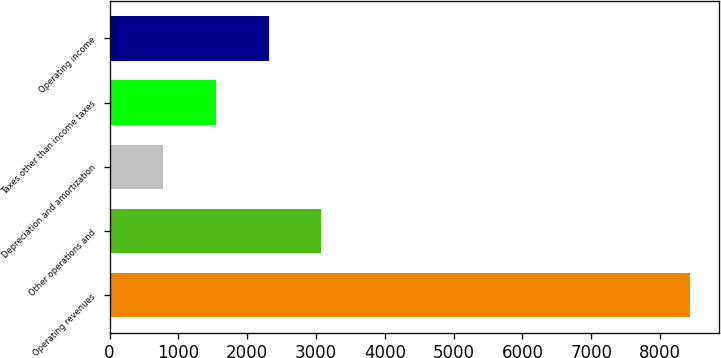Convert chart. <chart><loc_0><loc_0><loc_500><loc_500><bar_chart><fcel>Operating revenues<fcel>Other operations and<fcel>Depreciation and amortization<fcel>Taxes other than income taxes<fcel>Operating income<nl><fcel>8437<fcel>3077.8<fcel>781<fcel>1546.6<fcel>2312.2<nl></chart> 